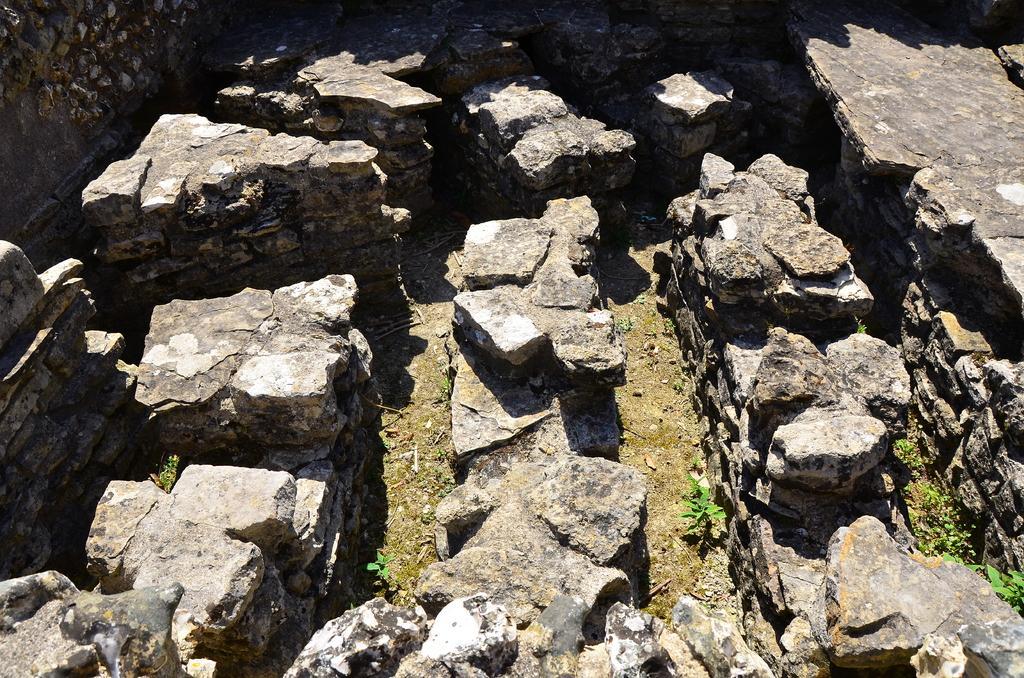Describe this image in one or two sentences. In the image there are few rocks, they are surrounded with a wall made up of stones. 